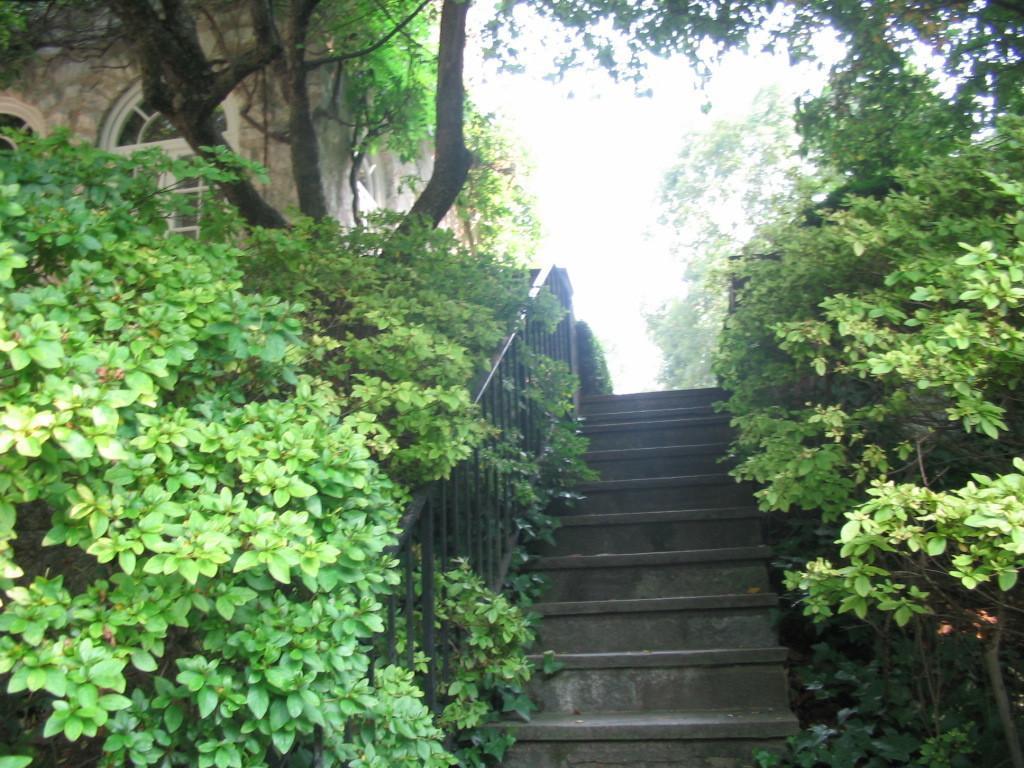Could you give a brief overview of what you see in this image? This image consists of tree and plants on the left and right. In the middle, there are steps along with a railing. On the left, we can see a building. At the top, there is sky. 